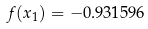<formula> <loc_0><loc_0><loc_500><loc_500>f ( x _ { 1 } ) = - 0 . 9 3 1 5 9 6</formula> 